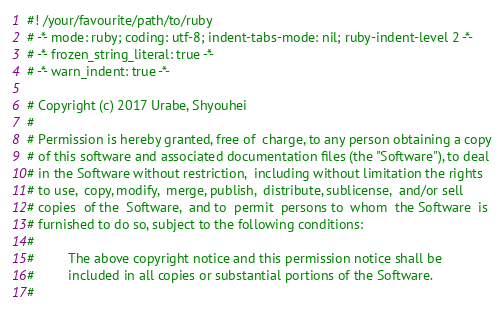Convert code to text. <code><loc_0><loc_0><loc_500><loc_500><_Ruby_>#! /your/favourite/path/to/ruby
# -*- mode: ruby; coding: utf-8; indent-tabs-mode: nil; ruby-indent-level 2 -*-
# -*- frozen_string_literal: true -*-
# -*- warn_indent: true -*-

# Copyright (c) 2017 Urabe, Shyouhei
#
# Permission is hereby granted, free of  charge, to any person obtaining a copy
# of this software and associated documentation files (the "Software"), to deal
# in the Software without restriction,  including without limitation the rights
# to use,  copy, modify,  merge, publish,  distribute, sublicense,  and/or sell
# copies  of the  Software,  and to  permit  persons to  whom  the Software  is
# furnished to do so, subject to the following conditions:
#
#         The above copyright notice and this permission notice shall be
#         included in all copies or substantial portions of the Software.
#</code> 